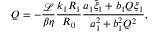Convert formula to latex. <formula><loc_0><loc_0><loc_500><loc_500>Q = - \frac { \mathcal { L } } { \beta \eta } \frac { k _ { 1 } R _ { 1 } } { R _ { 0 } } \frac { a _ { 1 } \tilde { \xi } _ { 1 } + b _ { 1 } Q \xi _ { 1 } } { a _ { 1 } ^ { 2 } + b _ { 1 } ^ { 2 } Q ^ { 2 } } ,</formula> 